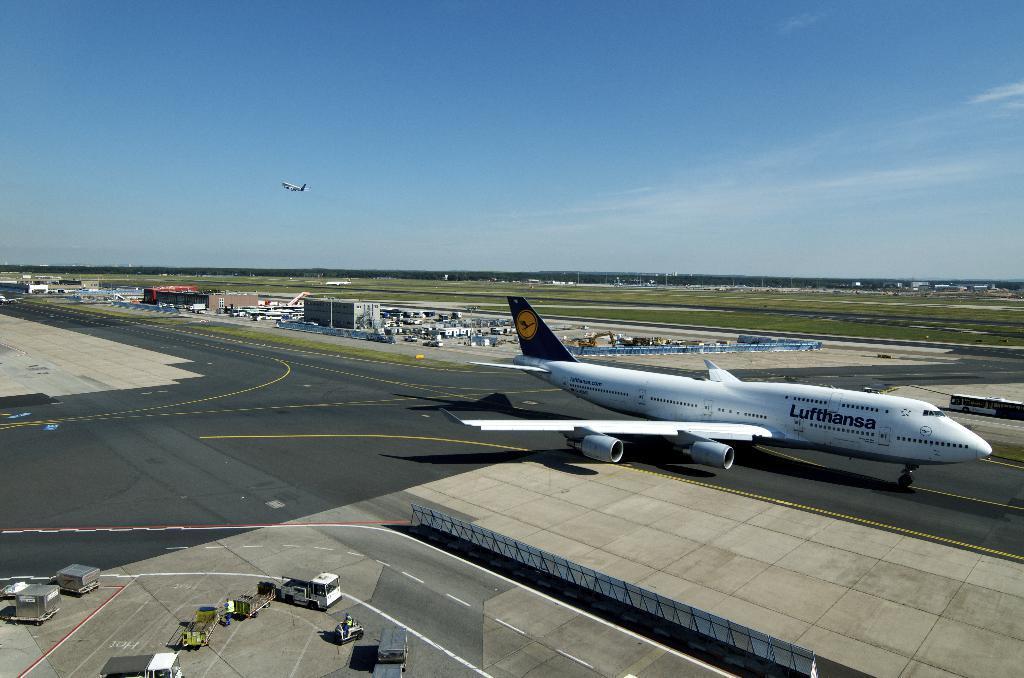Could you give a brief overview of what you see in this image? In this image I can see there is an airplane on the ground and the other airplane flying in the sky. And there are vehicles on the ground. And there is an object. And there are grass and trees. And there are buildings and a sky. 